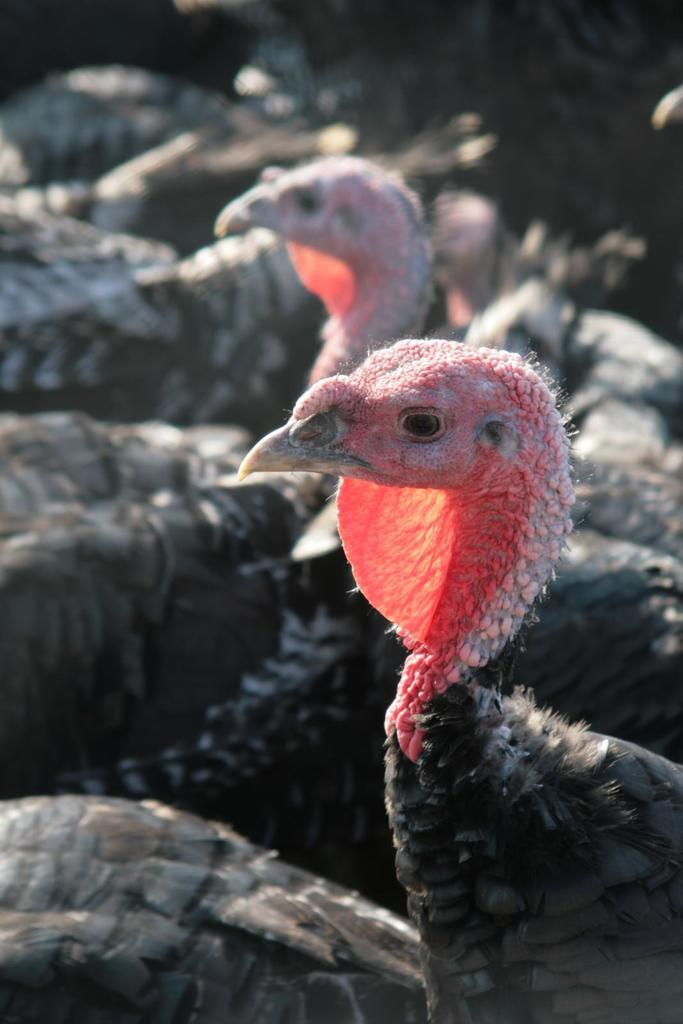What type of animals are present in the image? There is a group of birds in the image. What can be observed about the background of the image? The background of the image is dark. What type of question is being asked by the birds in the image? There is no indication in the image that the birds are asking a question. 